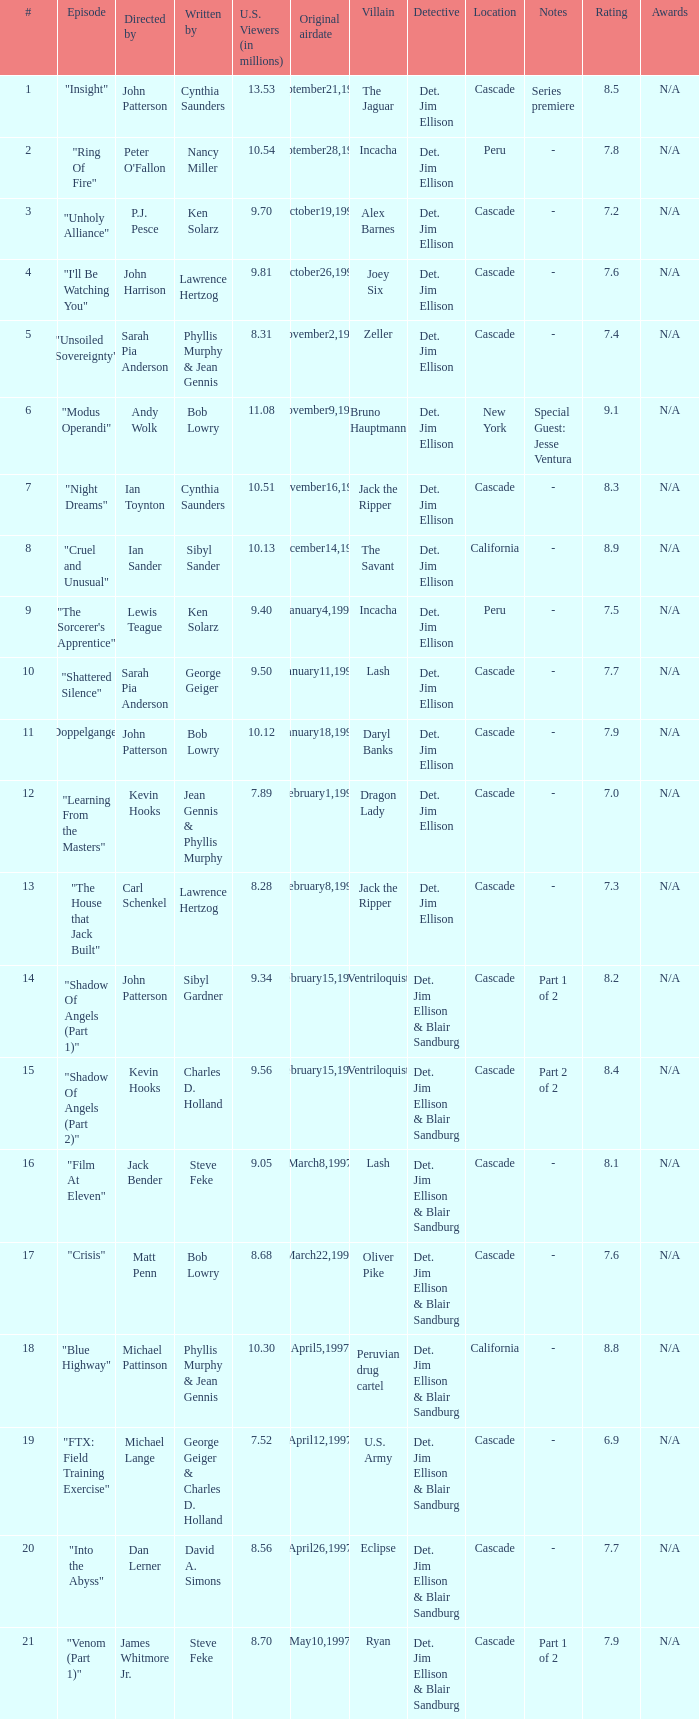Who wrote the episode with 9.81 million US viewers? Lawrence Hertzog. 